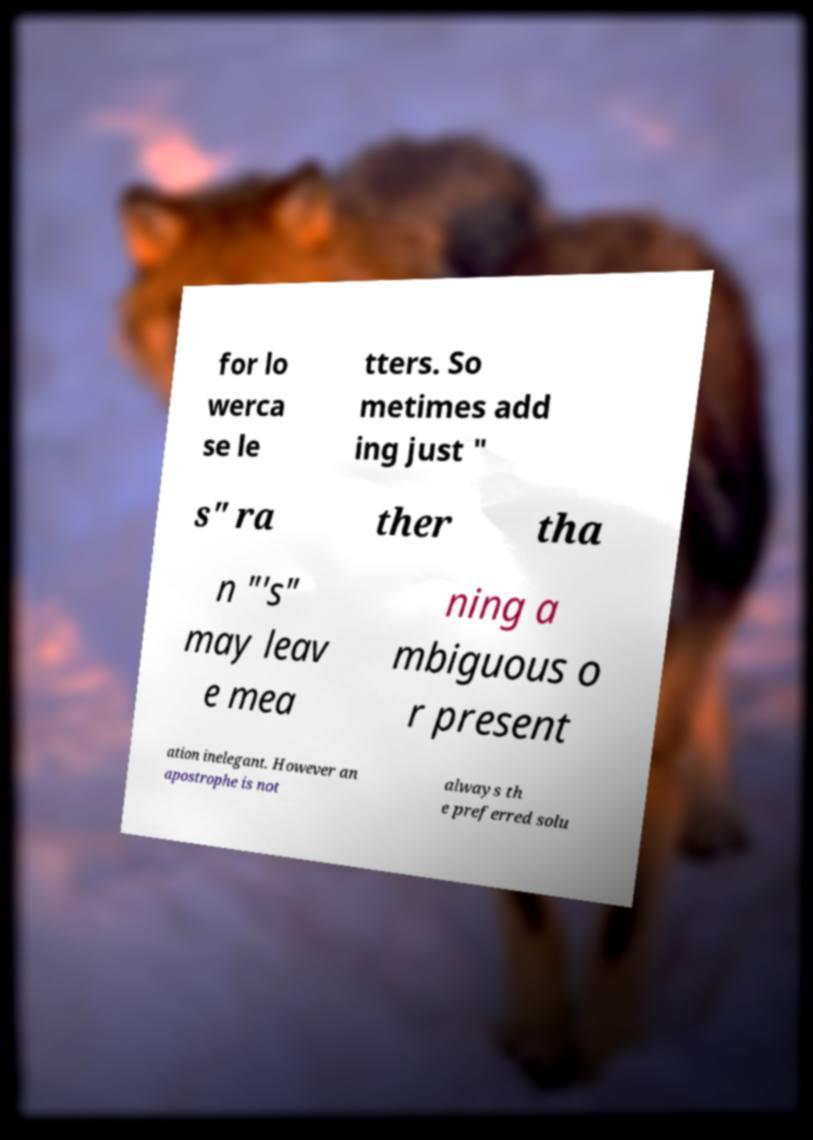For documentation purposes, I need the text within this image transcribed. Could you provide that? for lo werca se le tters. So metimes add ing just " s" ra ther tha n "'s" may leav e mea ning a mbiguous o r present ation inelegant. However an apostrophe is not always th e preferred solu 